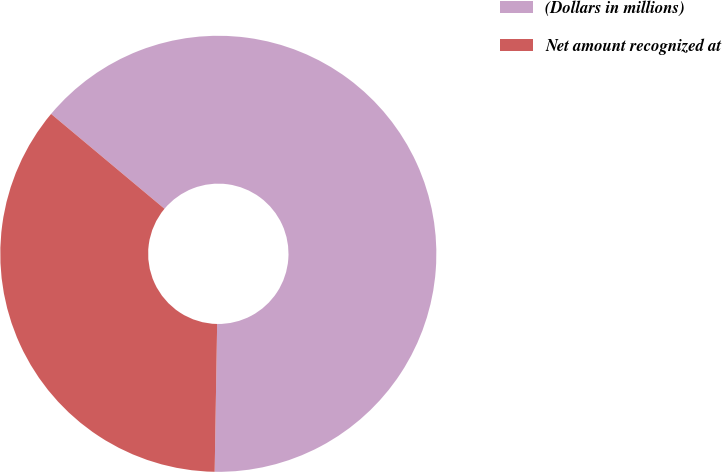Convert chart. <chart><loc_0><loc_0><loc_500><loc_500><pie_chart><fcel>(Dollars in millions)<fcel>Net amount recognized at<nl><fcel>64.18%<fcel>35.82%<nl></chart> 